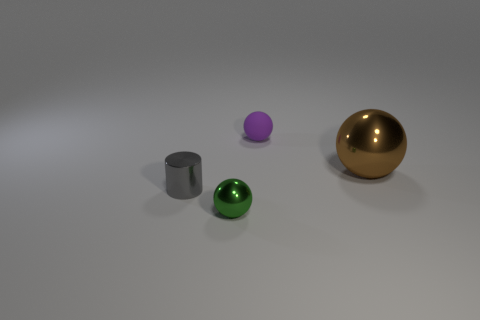Add 1 big blocks. How many objects exist? 5 Subtract all balls. How many objects are left? 1 Subtract all tiny gray shiny objects. Subtract all big objects. How many objects are left? 2 Add 3 green shiny balls. How many green shiny balls are left? 4 Add 3 big metallic objects. How many big metallic objects exist? 4 Subtract 0 blue cylinders. How many objects are left? 4 